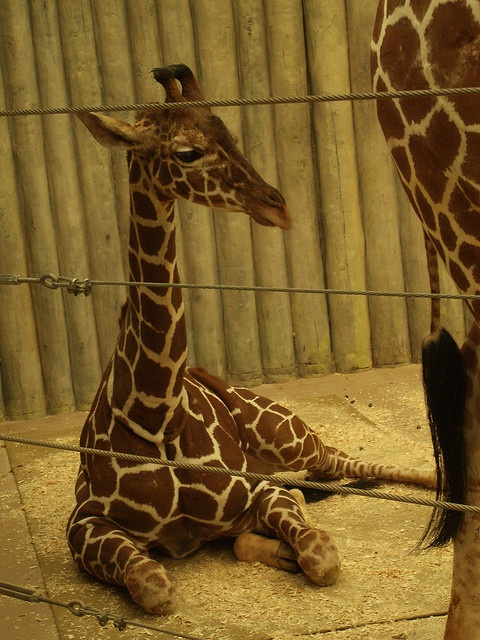Describe the objects in this image and their specific colors. I can see giraffe in olive, black, and maroon tones and giraffe in olive, maroon, and black tones in this image. 